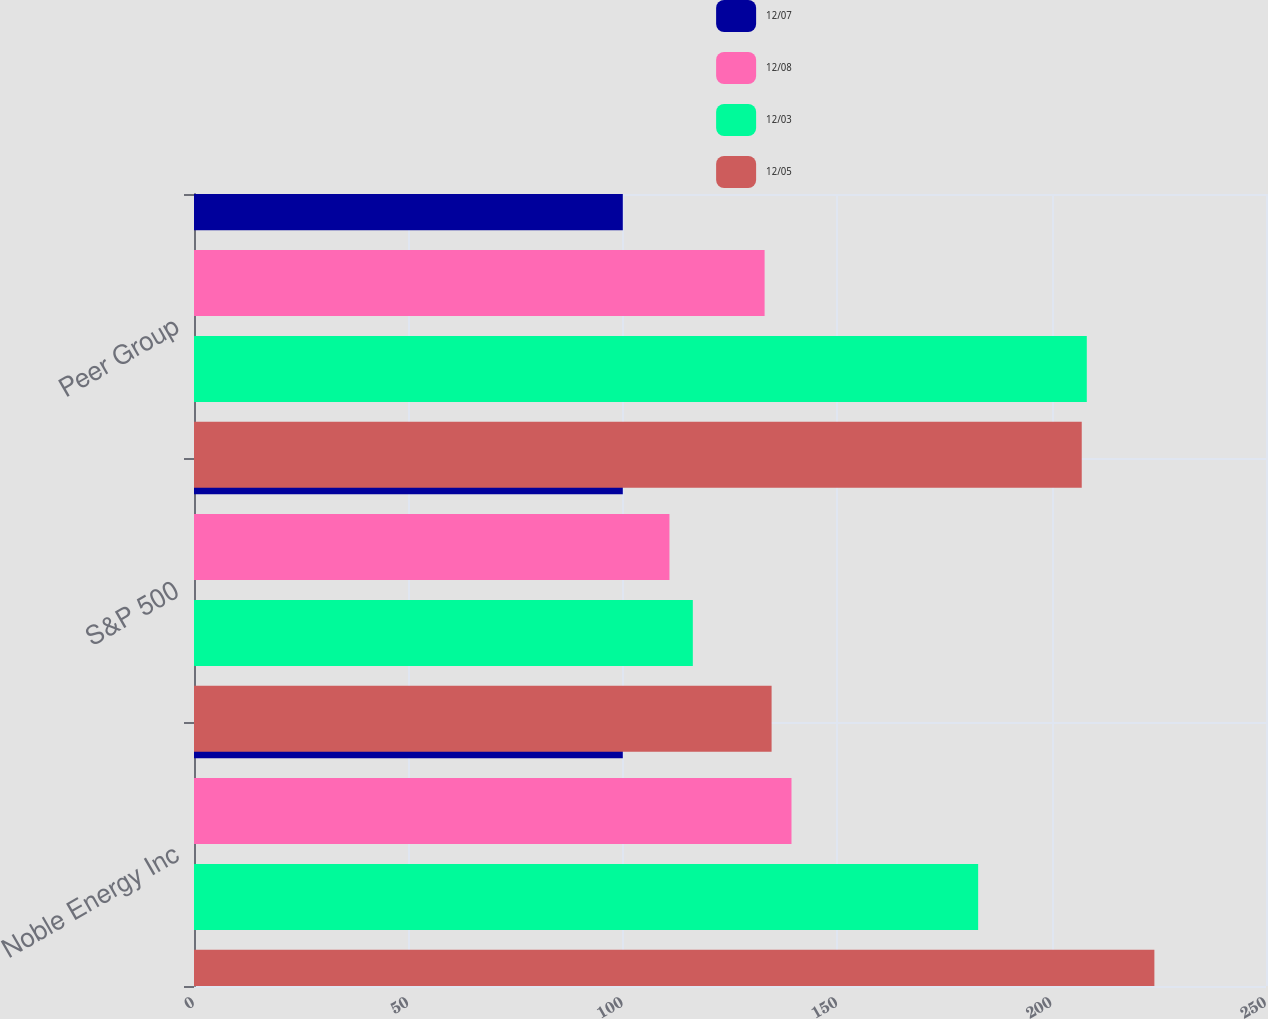Convert chart to OTSL. <chart><loc_0><loc_0><loc_500><loc_500><stacked_bar_chart><ecel><fcel>Noble Energy Inc<fcel>S&P 500<fcel>Peer Group<nl><fcel>12/07<fcel>100<fcel>100<fcel>100<nl><fcel>12/08<fcel>139.34<fcel>110.88<fcel>133.07<nl><fcel>12/03<fcel>182.87<fcel>116.33<fcel>208.21<nl><fcel>12/05<fcel>223.97<fcel>134.7<fcel>207.03<nl></chart> 